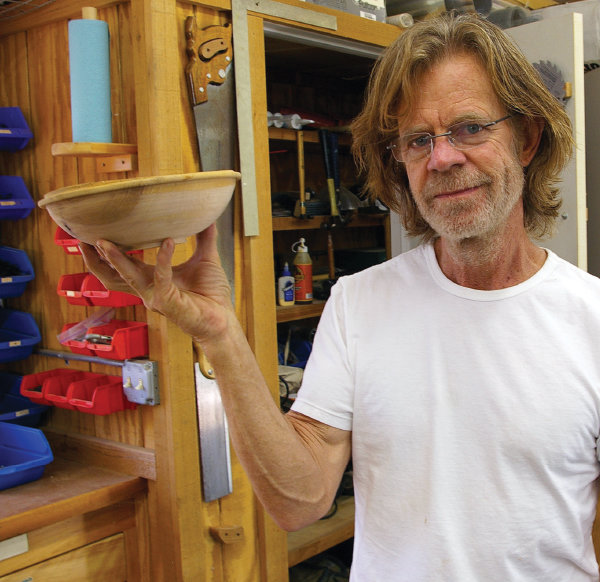Analyze the image in a comprehensive and detailed manner.
 In this image, we see the renowned actor William H Macy, known for his roles in films and television series, standing in a woodshop. He is holding a wooden bowl in his right hand, perhaps a product of his woodworking skills. Dressed casually in a white t-shirt and sporting a pair of glasses, he looks directly at the camera with a slight smile on his face, giving us a glimpse of his off-screen persona. The background is filled with various woodworking tools and supplies neatly arranged on shelves and walls, indicating a well-used and organized workspace. This image captures a moment of Macy's life away from the spotlight, indulging in his hobby. 